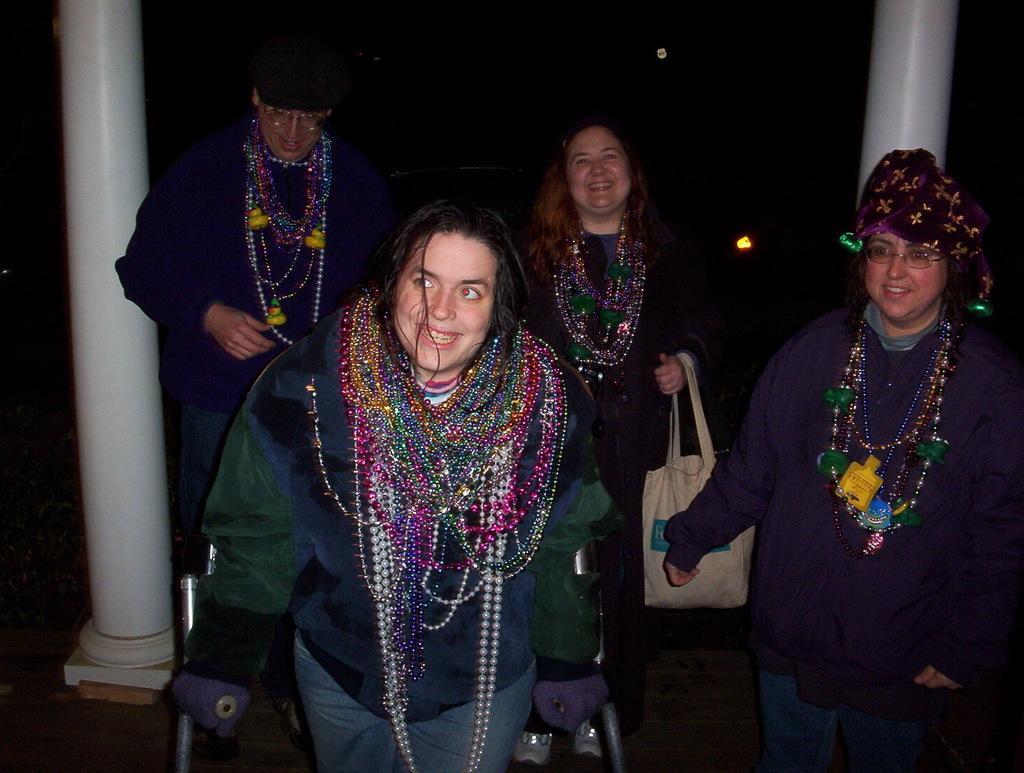How would you summarize this image in a sentence or two? In this image I can see four persons standing and smiling. At the back of these people there are two pillars. The background is in black color. 